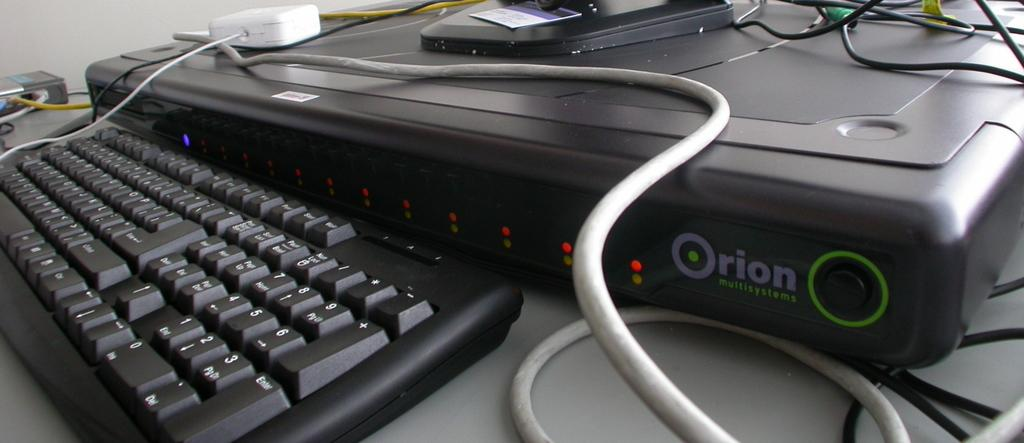Provide a one-sentence caption for the provided image. a digital device in front of a keyboard that says 'orion' on it. 